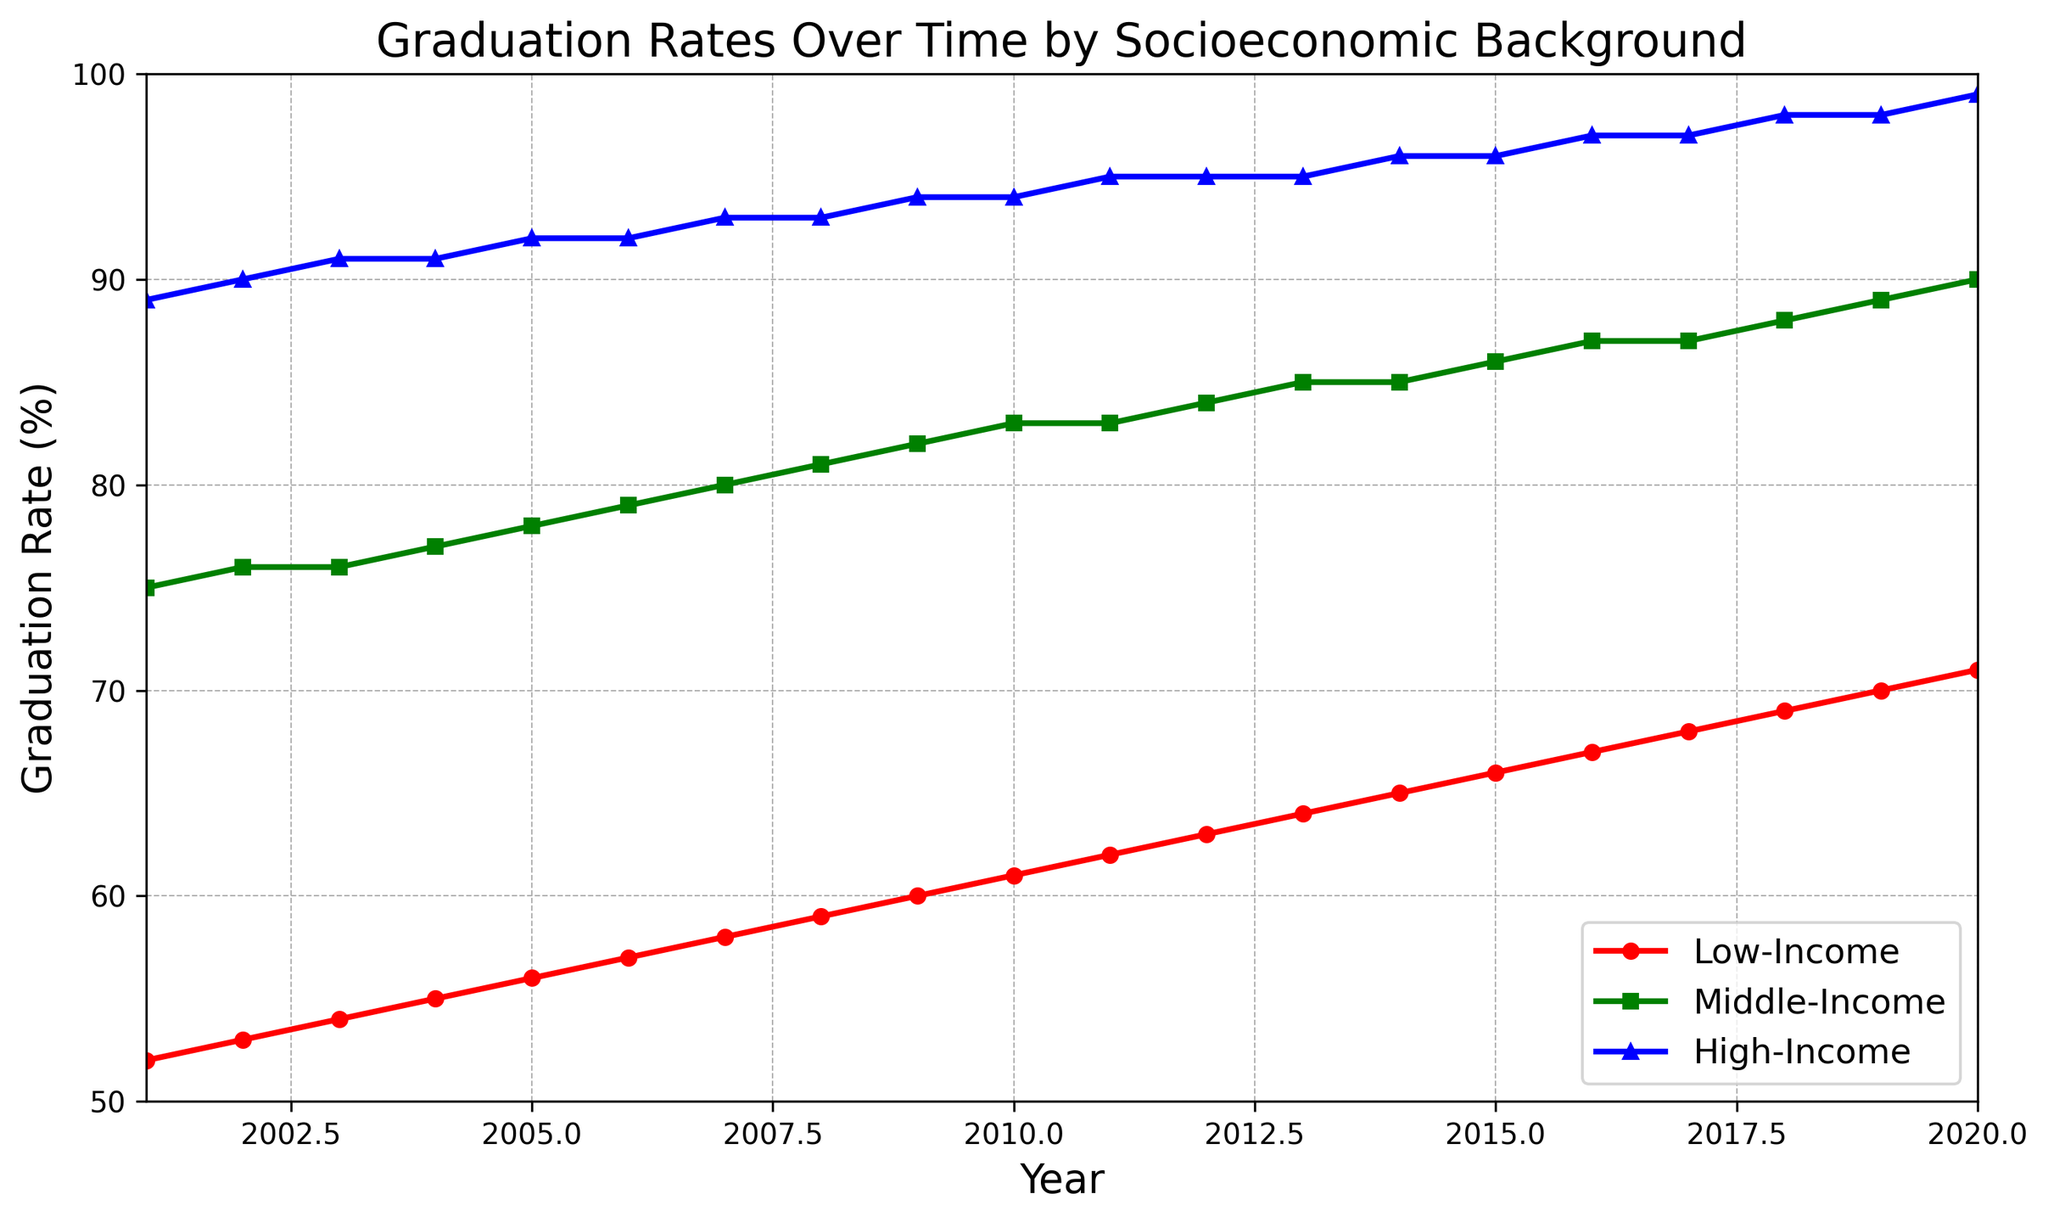What is the graduation rate for low-income students in 2010? Locate the point representing the year 2010 on the x-axis. The corresponding graduation rate for low-income students (marked in red) reads 61%.
Answer: 61% How much did the graduation rate for middle-income students increase from 2001 to 2010? The graduation rate for middle-income students in 2001 is 75%, and in 2010 it is 83%. Calculate the increase: 83% - 75% = 8%.
Answer: 8% Which income group had the highest graduation rate in 2020? Find the year 2020 on the x-axis and compare the values for each income group. High-income students (marked in blue) have the highest rate at 99%.
Answer: High-Income Between which consecutive years did the low-income group see the largest increase in graduation rates? Look for the steepest slope in the red line representing low-income students. The largest increase is between 2018 and 2019, where it increases from 69% to 70%.
Answer: 2018-2019 What is the difference in graduation rates between high-income and low-income students in 2005? In 2005, the graduation rate for high-income students is 92%, and for low-income students, it is 56%. Calculate the difference: 92% - 56% = 36%.
Answer: 36% How has the graduation rate for high-income students changed over the 20 years? The graduation rate for high-income students starts at 89% in 2001 and rises to 99% in 2020. Overall, it shows a steady upward trend over the 20 years.
Answer: Steady increase Which income group shows the most consistent yearly improvement in graduation rates? Observing the slopes of the lines, the high-income group (blue line) has a consistent upward trend with slight increases each year.
Answer: High-Income In which year did the middle-income graduation rate exceed 85%? Find the point on the green line where it first reaches or exceeds 85%. This first occurs in 2013, where the rate is 85%.
Answer: 2013 